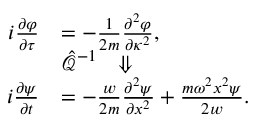Convert formula to latex. <formula><loc_0><loc_0><loc_500><loc_500>\begin{array} { r l } { i \frac { \partial \varphi } { \partial \tau } } & { = - \frac { 1 } { 2 m } \frac { \partial ^ { 2 } \varphi } { \partial \kappa ^ { 2 } } , } \\ & { \hat { \mathcal { Q } } ^ { - 1 } \Downarrow } \\ { i \frac { \partial \psi } { \partial t } } & { = - \frac { w } { 2 m } \frac { \partial ^ { 2 } \psi } { \partial x ^ { 2 } } + \frac { m \omega ^ { 2 } x ^ { 2 } \psi } { 2 w } . } \end{array}</formula> 